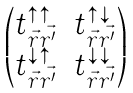<formula> <loc_0><loc_0><loc_500><loc_500>\begin{pmatrix} t _ { \vec { r } \vec { r ^ { \prime } } } ^ { \uparrow \uparrow } & t _ { \vec { r } \vec { r ^ { \prime } } } ^ { \uparrow \downarrow } \\ t _ { \vec { r } \vec { r ^ { \prime } } } ^ { \downarrow \uparrow } & t _ { \vec { r } \vec { r ^ { \prime } } } ^ { \downarrow \downarrow } \end{pmatrix}</formula> 